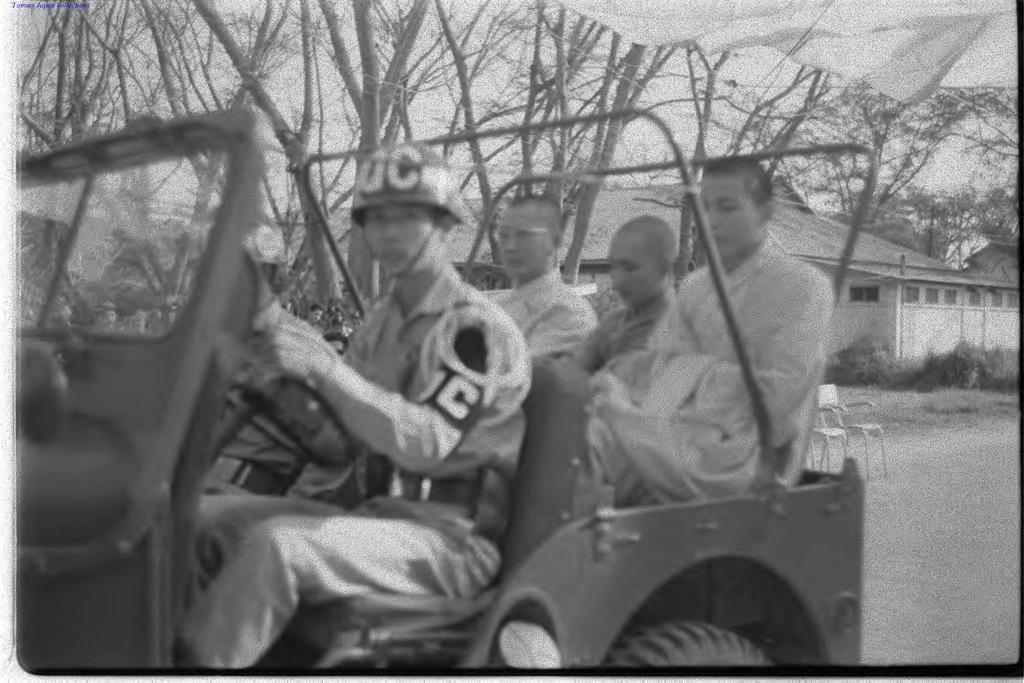What are the people in the image doing? The persons in the image are sitting in a vehicle. Where is the vehicle located? The vehicle is on the road. What can be seen in the background of the image? There are trees and a house in the background of the image. What type of rhythm is being played by the industry in the background of the image? There is no industry or rhythm present in the image; it features a vehicle with persons sitting inside and a background with trees and a house. 